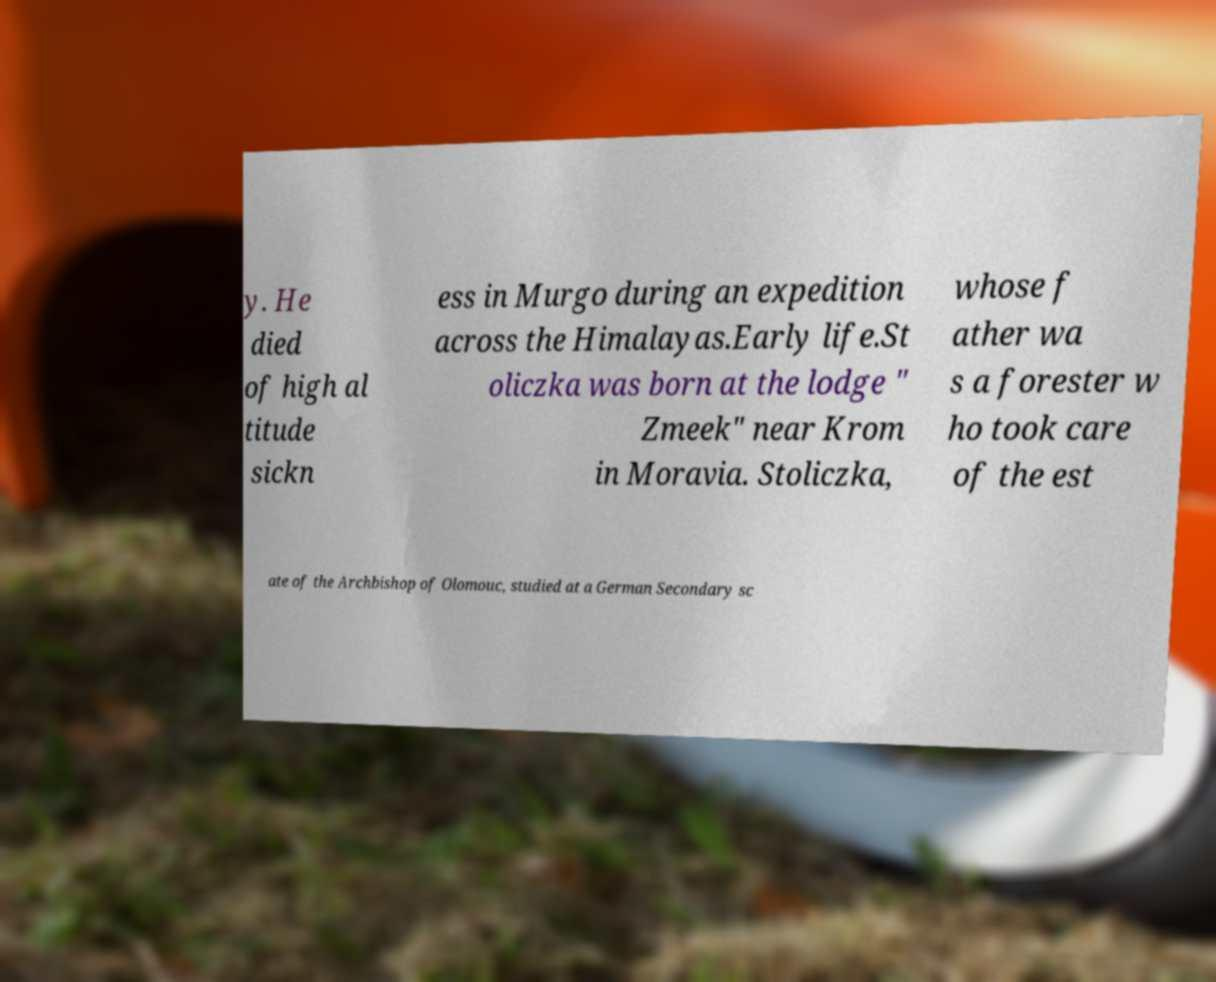What messages or text are displayed in this image? I need them in a readable, typed format. y. He died of high al titude sickn ess in Murgo during an expedition across the Himalayas.Early life.St oliczka was born at the lodge " Zmeek" near Krom in Moravia. Stoliczka, whose f ather wa s a forester w ho took care of the est ate of the Archbishop of Olomouc, studied at a German Secondary sc 